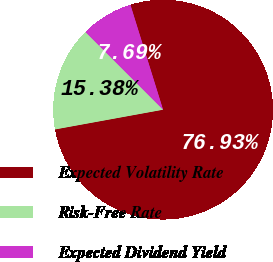<chart> <loc_0><loc_0><loc_500><loc_500><pie_chart><fcel>Expected Volatility Rate<fcel>Risk-Free Rate<fcel>Expected Dividend Yield<nl><fcel>76.92%<fcel>15.38%<fcel>7.69%<nl></chart> 